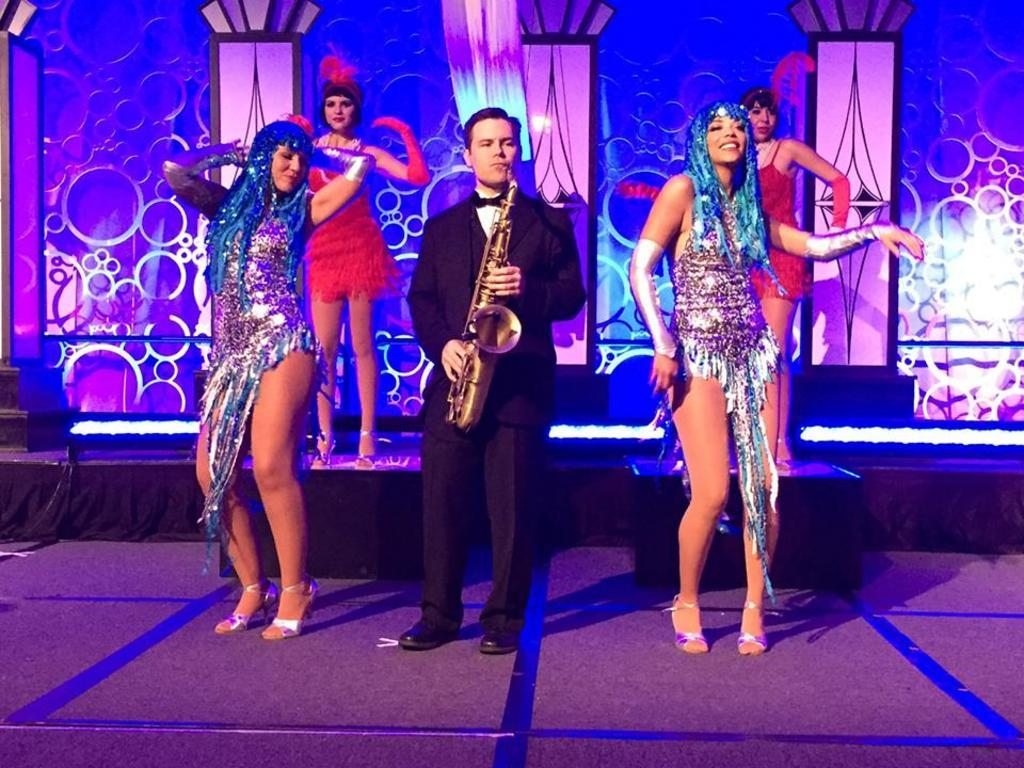What is the main subject of the image? There is a person playing a saxophone in the image. What are the other people in the image doing? There are 4 women dancing in the image. Can you describe the background of the image? The background of the image is colorful. What type of shoes is the person's aunt wearing in the image? There is no mention of an aunt or shoes in the image, so this information cannot be provided. 